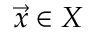<formula> <loc_0><loc_0><loc_500><loc_500>{ \vec { x } } \in X</formula> 